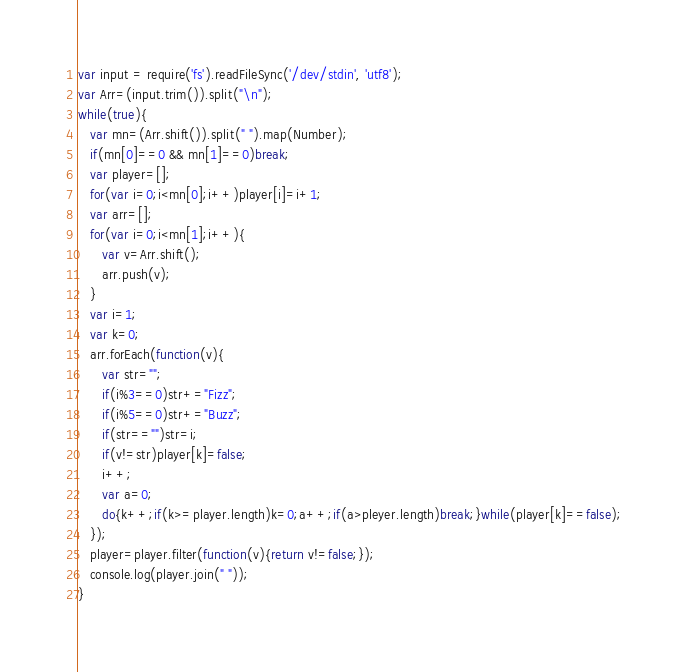Convert code to text. <code><loc_0><loc_0><loc_500><loc_500><_JavaScript_>var input = require('fs').readFileSync('/dev/stdin', 'utf8');
var Arr=(input.trim()).split("\n");
while(true){
   var mn=(Arr.shift()).split(" ").map(Number);
   if(mn[0]==0 && mn[1]==0)break;
   var player=[];
   for(var i=0;i<mn[0];i++)player[i]=i+1;
   var arr=[];
   for(var i=0;i<mn[1];i++){
      var v=Arr.shift();
      arr.push(v);
   }
   var i=1;
   var k=0;
   arr.forEach(function(v){
      var str="";
      if(i%3==0)str+="Fizz";
      if(i%5==0)str+="Buzz";
      if(str=="")str=i;
      if(v!=str)player[k]=false;
      i++;
      var a=0;
      do{k++;if(k>=player.length)k=0;a++;if(a>pleyer.length)break;}while(player[k]==false);
   });
   player=player.filter(function(v){return v!=false;});
   console.log(player.join(" "));
}</code> 